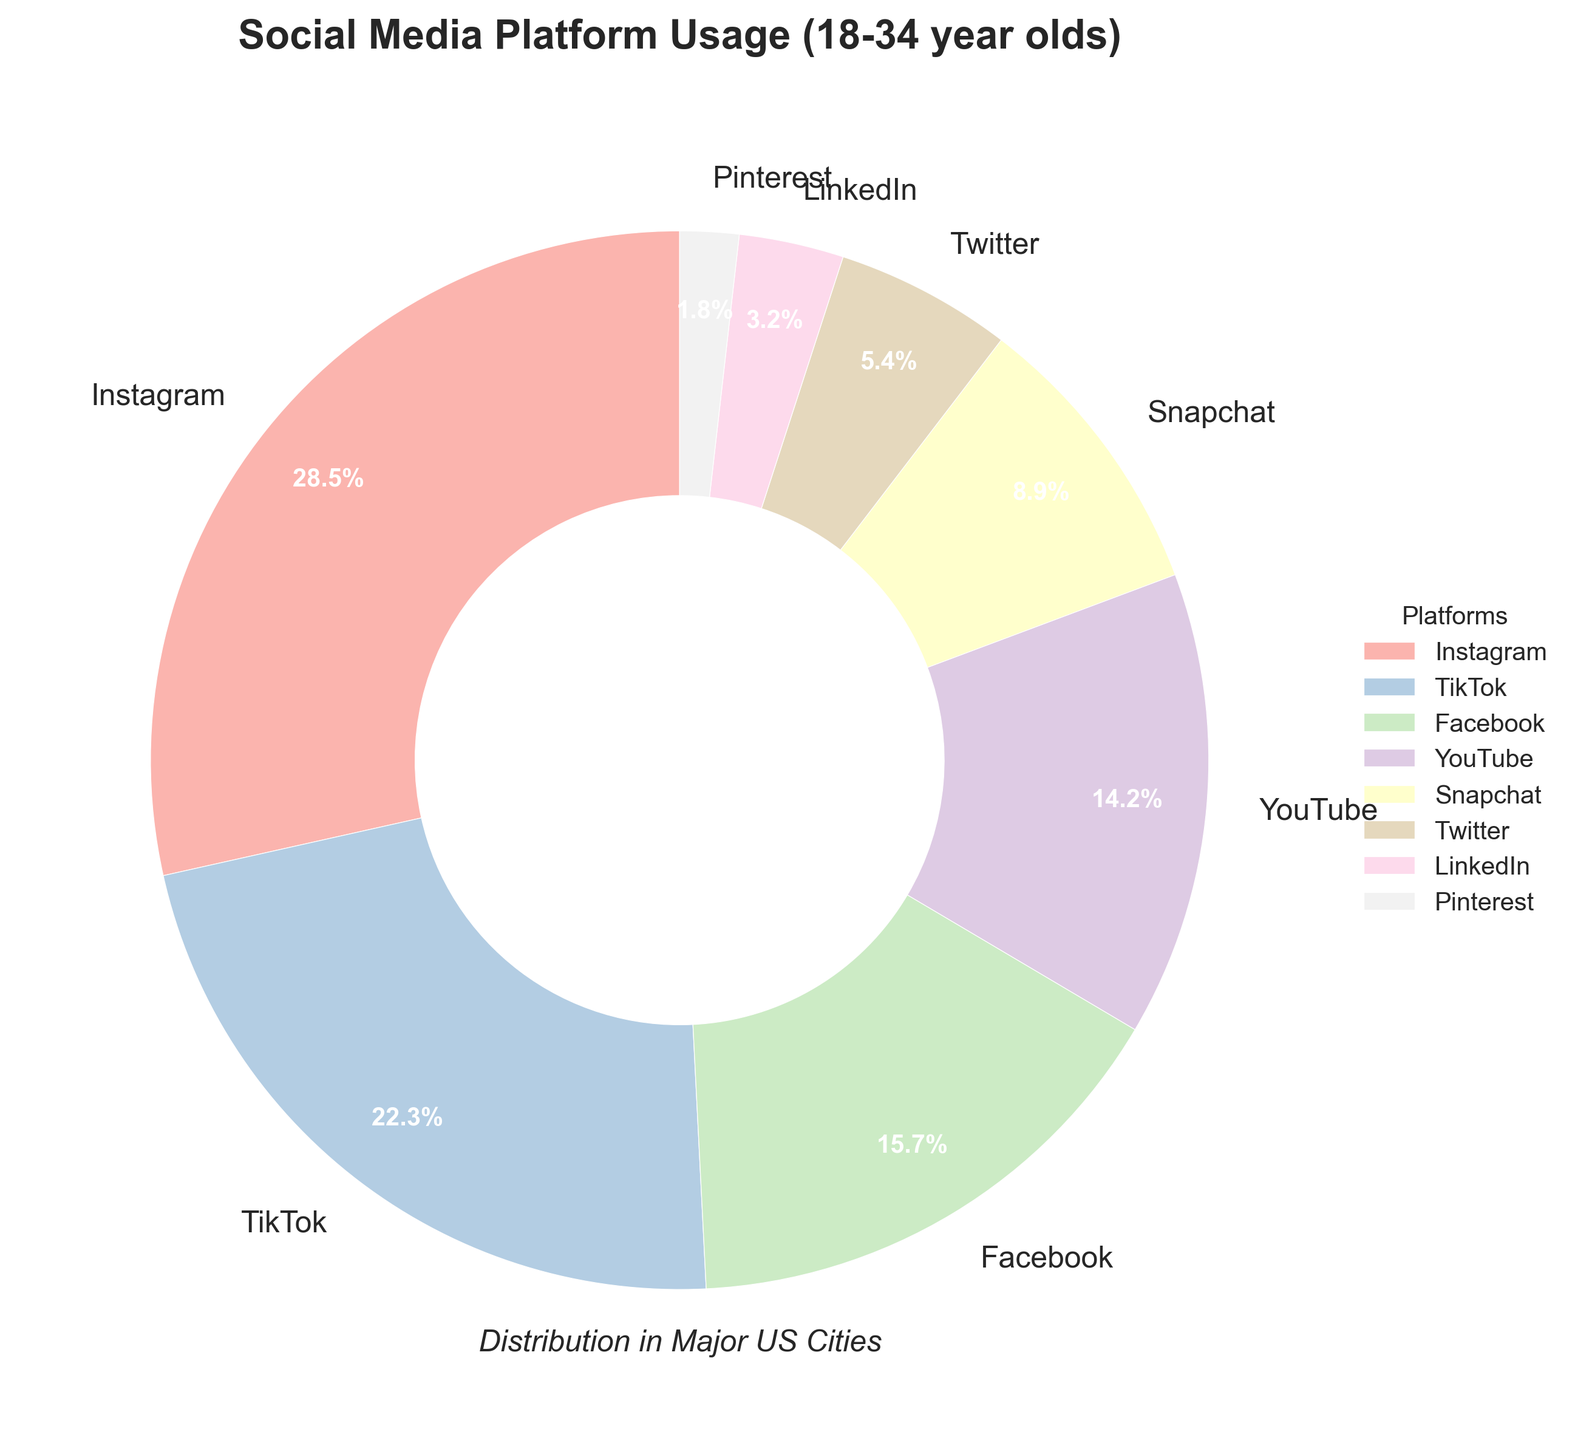Which platform has the highest usage percentage among 18-34 year olds in major US cities? By examining the pie chart, it's clear that the largest section belongs to Instagram, which also has the highest percentage value of 28.5%.
Answer: Instagram What is the combined usage percentage of TikTok and Facebook? Add the percentages of TikTok and Facebook. TikTok has 22.3% and Facebook has 15.7%. Therefore, the combined usage percentage is 22.3% + 15.7% = 38%.
Answer: 38% Which platform has a smaller usage percentage: Snapchat or Twitter? Compare the wedge sizes for Snapchat and Twitter, or check the percentages. Snapchat has 8.9% whereas Twitter has 5.4%. Thus, Twitter has a smaller usage percentage.
Answer: Twitter What percentage of 18-34 year olds use platforms other than Instagram and TikTok? Subtract the combined usage percentage of Instagram and TikTok from 100%. Instagram has 28.5% and TikTok has 22.3%, so combined they have 50.8%. 100% - 50.8% = 49.2%.
Answer: 49.2% Arrange the platforms in descending order of their usage percentages. List the platforms according to their percentages in descending order: Instagram (28.5%), TikTok (22.3%), Facebook (15.7%), YouTube (14.2%), Snapchat (8.9%), Twitter (5.4%), LinkedIn (3.2%), Pinterest (1.8%).
Answer: Instagram, TikTok, Facebook, YouTube, Snapchat, Twitter, LinkedIn, Pinterest Which has a larger usage percentage, LinkedIn or Pinterest? Compare the wedge sizes or percentages of LinkedIn and Pinterest. LinkedIn has 3.2% and Pinterest has 1.8%, so LinkedIn has a larger usage percentage.
Answer: LinkedIn How does the usage percentage of YouTube compare to Snapchat? Compare the usage percentages of YouTube and Snapchat. YouTube has 14.2% and Snapchat has 8.9%. So, YouTube has a higher usage percentage.
Answer: YouTube What is the difference in usage percentage between Facebook and LinkedIn? Subtract the percentage of LinkedIn from the percentage of Facebook. Facebook has 15.7% and LinkedIn has 3.2%. The difference is 15.7% - 3.2% = 12.5%.
Answer: 12.5% Which platform forms the smallest wedge in the pie chart? Visually inspect the pie chart for the smallest wedge or check the percentage values. The smallest wedge is for Pinterest with 1.8%.
Answer: Pinterest What is the total usage percentage for platforms with less than 10% usage each? Add the percentages of platforms with less than 10% usage: Snapchat (8.9%), Twitter (5.4%), LinkedIn (3.2%), Pinterest (1.8%). The total is 8.9% + 5.4% + 3.2% + 1.8% = 19.3%.
Answer: 19.3% 